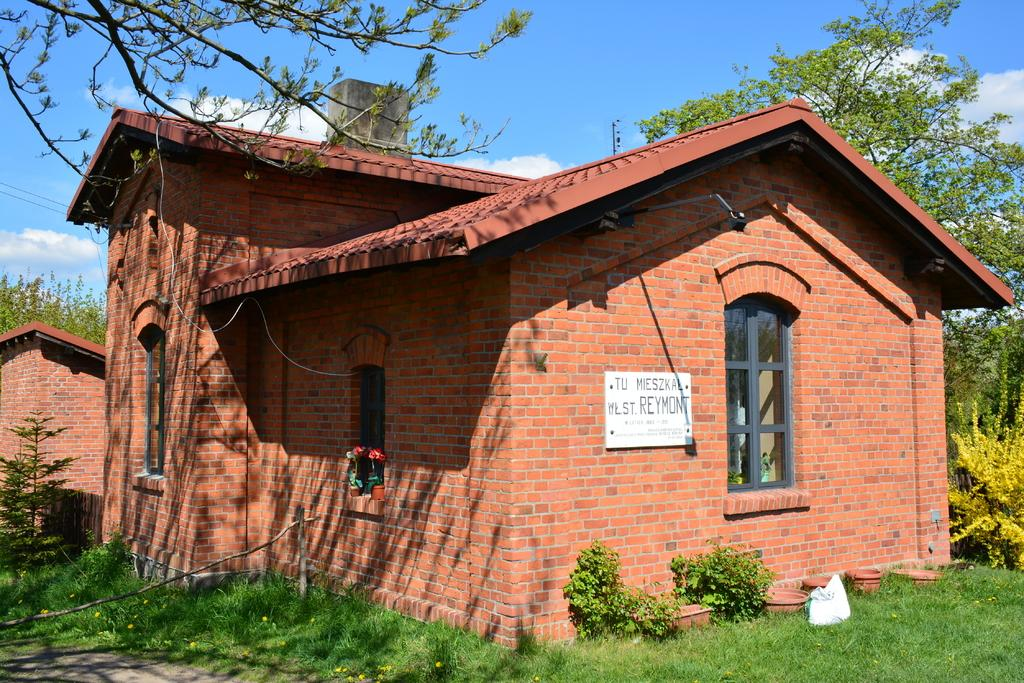What type of house is in the image? There is a brick house in the image. What type of vegetation is present in the image? There is grass, plants, and trees in the image. What type of barrier is in the image? There is a fence in the image. What type of containers are in the image? There are flower pots in the image. What type of sign is in the image? There is a board in the image. What can be seen in the background of the image? The sky is visible in the background of the image, with clouds present. How many beds are visible in the image? There are no beds present in the image. What type of bean is growing in the flower pots in the image? There are no beans growing in the flower pots in the image; they contain plants. 